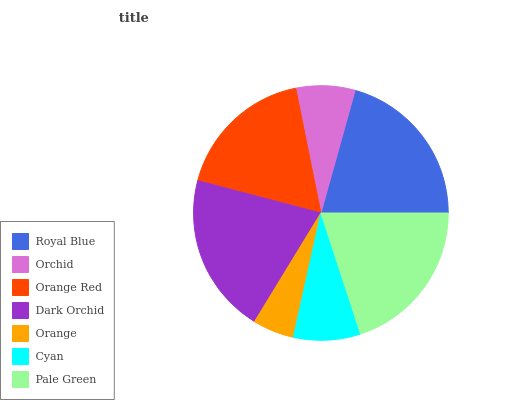Is Orange the minimum?
Answer yes or no. Yes. Is Royal Blue the maximum?
Answer yes or no. Yes. Is Orchid the minimum?
Answer yes or no. No. Is Orchid the maximum?
Answer yes or no. No. Is Royal Blue greater than Orchid?
Answer yes or no. Yes. Is Orchid less than Royal Blue?
Answer yes or no. Yes. Is Orchid greater than Royal Blue?
Answer yes or no. No. Is Royal Blue less than Orchid?
Answer yes or no. No. Is Orange Red the high median?
Answer yes or no. Yes. Is Orange Red the low median?
Answer yes or no. Yes. Is Royal Blue the high median?
Answer yes or no. No. Is Dark Orchid the low median?
Answer yes or no. No. 